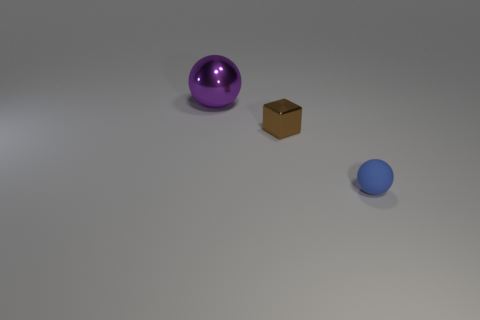What size is the thing that is made of the same material as the cube?
Keep it short and to the point. Large. The brown shiny block has what size?
Ensure brevity in your answer.  Small. What is the material of the brown object?
Your answer should be very brief. Metal. Does the shiny thing that is behind the cube have the same size as the tiny brown cube?
Your response must be concise. No. What number of objects are purple shiny things or yellow spheres?
Provide a succinct answer. 1. What size is the object that is in front of the purple thing and to the left of the small blue rubber thing?
Your response must be concise. Small. How many big balls are there?
Provide a succinct answer. 1. What number of cylinders are either green objects or tiny brown things?
Provide a succinct answer. 0. How many tiny shiny objects are left of the sphere that is behind the small object that is behind the blue matte ball?
Your response must be concise. 0. What is the color of the metal cube that is the same size as the matte ball?
Provide a short and direct response. Brown. 